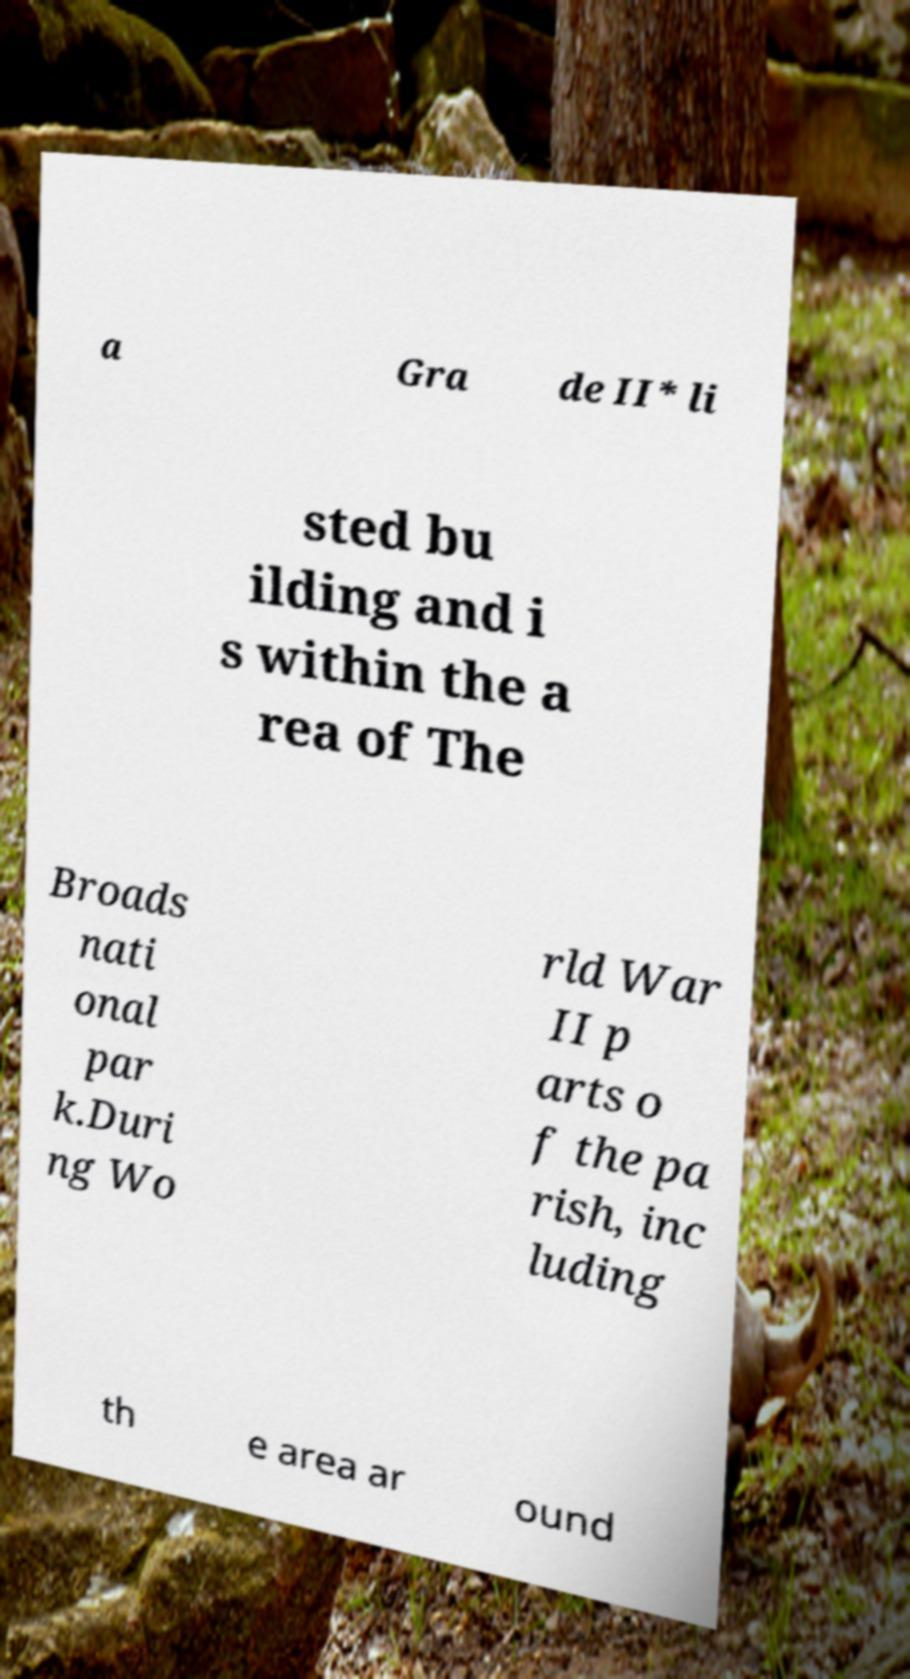Can you accurately transcribe the text from the provided image for me? a Gra de II* li sted bu ilding and i s within the a rea of The Broads nati onal par k.Duri ng Wo rld War II p arts o f the pa rish, inc luding th e area ar ound 